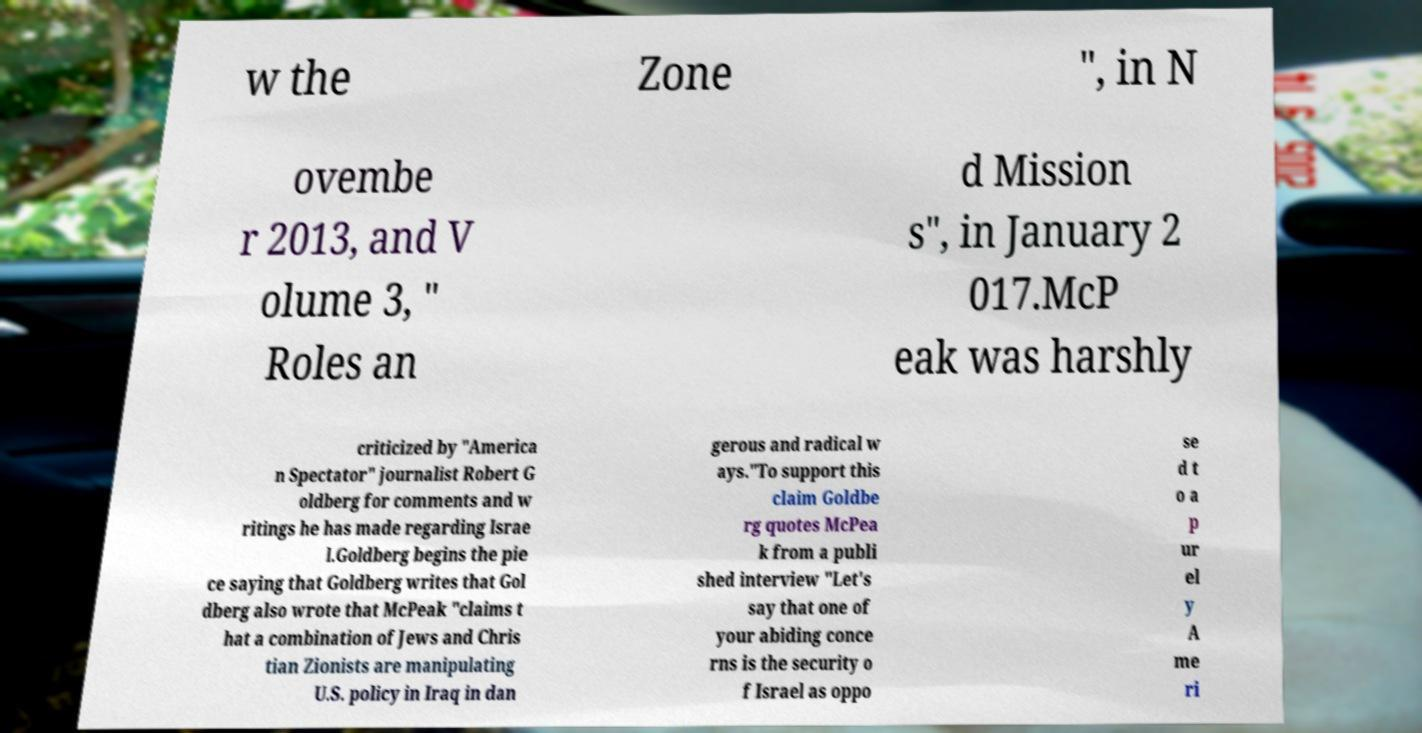I need the written content from this picture converted into text. Can you do that? w the Zone ", in N ovembe r 2013, and V olume 3, " Roles an d Mission s", in January 2 017.McP eak was harshly criticized by "America n Spectator" journalist Robert G oldberg for comments and w ritings he has made regarding Israe l.Goldberg begins the pie ce saying that Goldberg writes that Gol dberg also wrote that McPeak "claims t hat a combination of Jews and Chris tian Zionists are manipulating U.S. policy in Iraq in dan gerous and radical w ays."To support this claim Goldbe rg quotes McPea k from a publi shed interview "Let's say that one of your abiding conce rns is the security o f Israel as oppo se d t o a p ur el y A me ri 